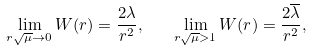Convert formula to latex. <formula><loc_0><loc_0><loc_500><loc_500>\lim _ { r \sqrt { \mu } \to 0 } W ( r ) = \frac { 2 \lambda } { r ^ { 2 } } , \quad \lim _ { r \sqrt { \mu } > 1 } W ( r ) = \frac { 2 \overline { \lambda } } { r ^ { 2 } } ,</formula> 